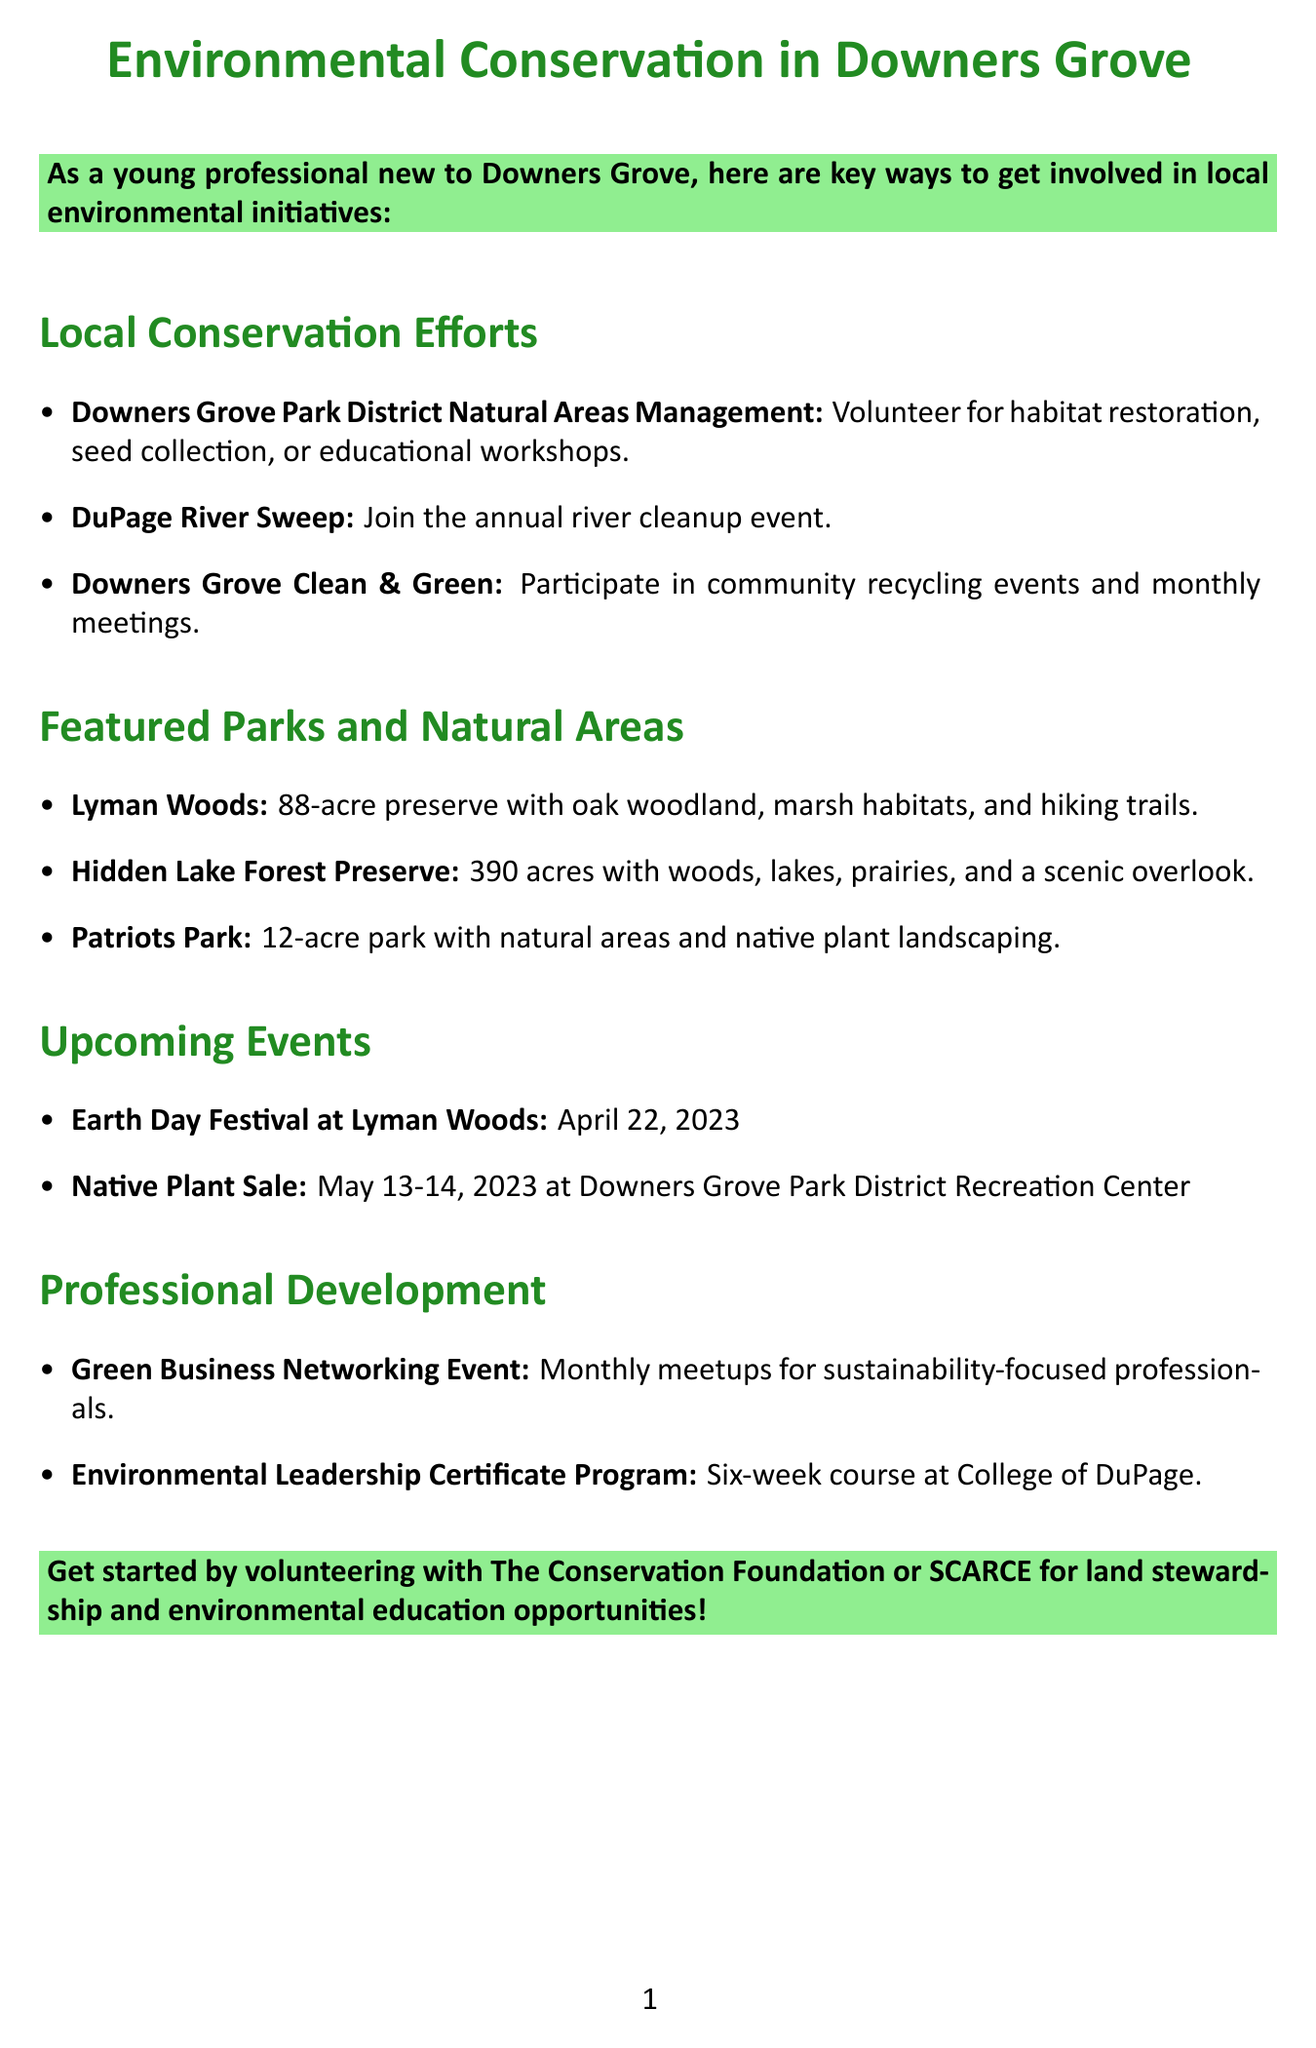What is the date of the Earth Day Festival? The Earth Day Festival is scheduled for April 22, 2023, as mentioned in the upcoming events section of the document.
Answer: April 22, 2023 What is the focus of the Downers Grove Clean & Green initiative? The Downers Grove Clean & Green initiative focuses on sustainability and community participation, as outlined under local conservation efforts.
Answer: Sustainability How many acres is the Hidden Lake Forest Preserve? The Hidden Lake Forest Preserve consists of 390 acres, which is specified in the featured parks section.
Answer: 390 acres What type of program does The Conservation Foundation offer? The Conservation Foundation offers volunteer opportunities related to land stewardship, as noted in the local environmental organizations section of the document.
Answer: Land stewardship What is one way to participate in the DuPage River Sweep? One way to participate in the DuPage River Sweep is to register as a volunteer for the cleanup event, which is detailed under local conservation efforts.
Answer: Register as a volunteer What does the Environmental Leadership Certificate Program provide? The Environmental Leadership Certificate Program provides a six-week course on environmental issues and leadership skills, as outlined in the professional development opportunities section.
Answer: Six-week course What is the main conservation focus of Lyman Woods? The main conservation focus of Lyman Woods is protecting rare plant species and wildlife habitats, which is specified in the featured parks section.
Answer: Protecting rare plant species and wildlife habitats How many miles of hiking trails are there in Lyman Woods? Lyman Woods has three miles of hiking trails, as noted in the features list for the park.
Answer: 3 miles 